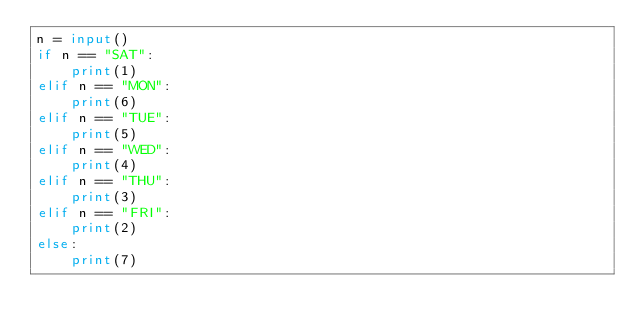Convert code to text. <code><loc_0><loc_0><loc_500><loc_500><_Python_>n = input()
if n == "SAT":
    print(1)
elif n == "MON":
    print(6)
elif n == "TUE":
    print(5)
elif n == "WED":
    print(4)
elif n == "THU":
    print(3)
elif n == "FRI":
    print(2)
else:
    print(7)</code> 